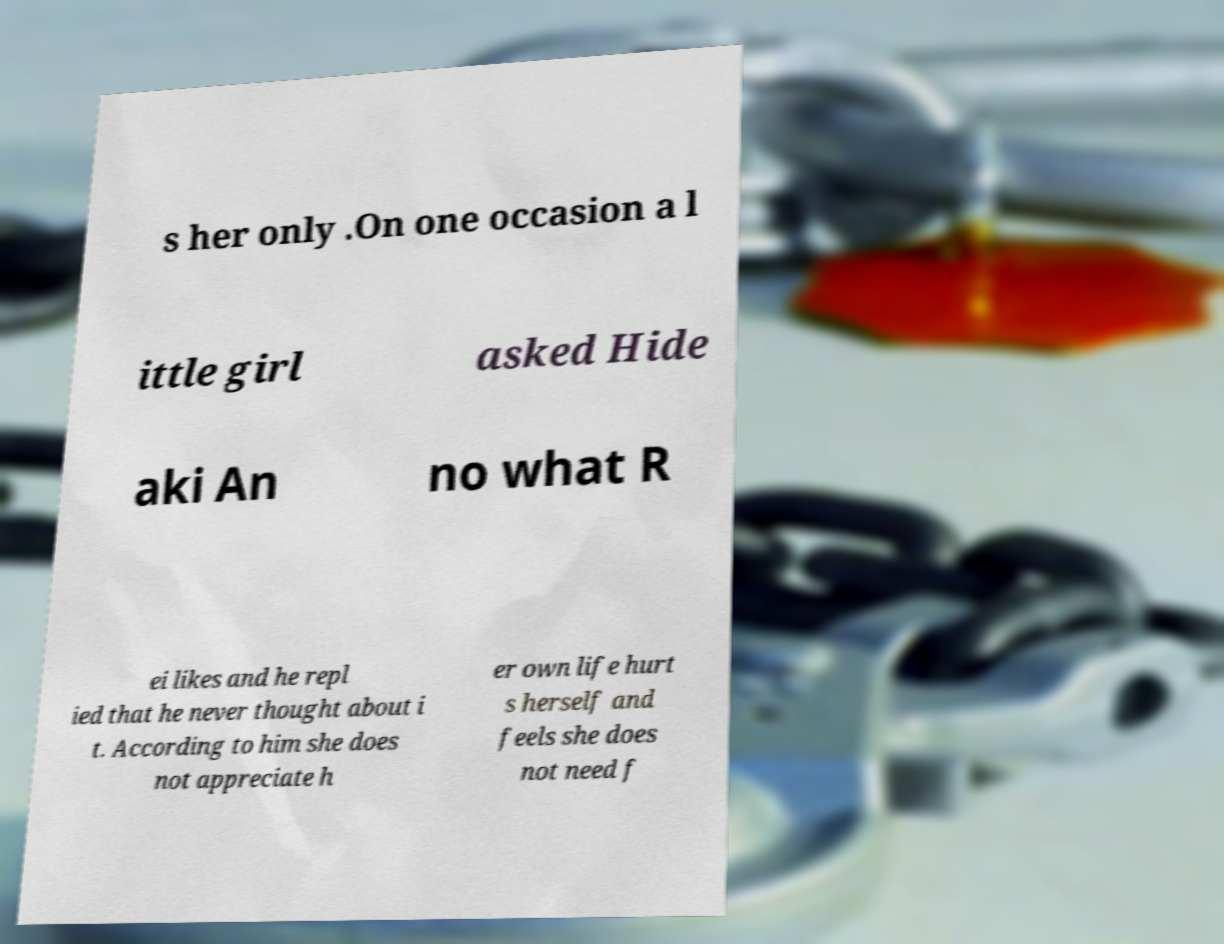Could you assist in decoding the text presented in this image and type it out clearly? s her only .On one occasion a l ittle girl asked Hide aki An no what R ei likes and he repl ied that he never thought about i t. According to him she does not appreciate h er own life hurt s herself and feels she does not need f 